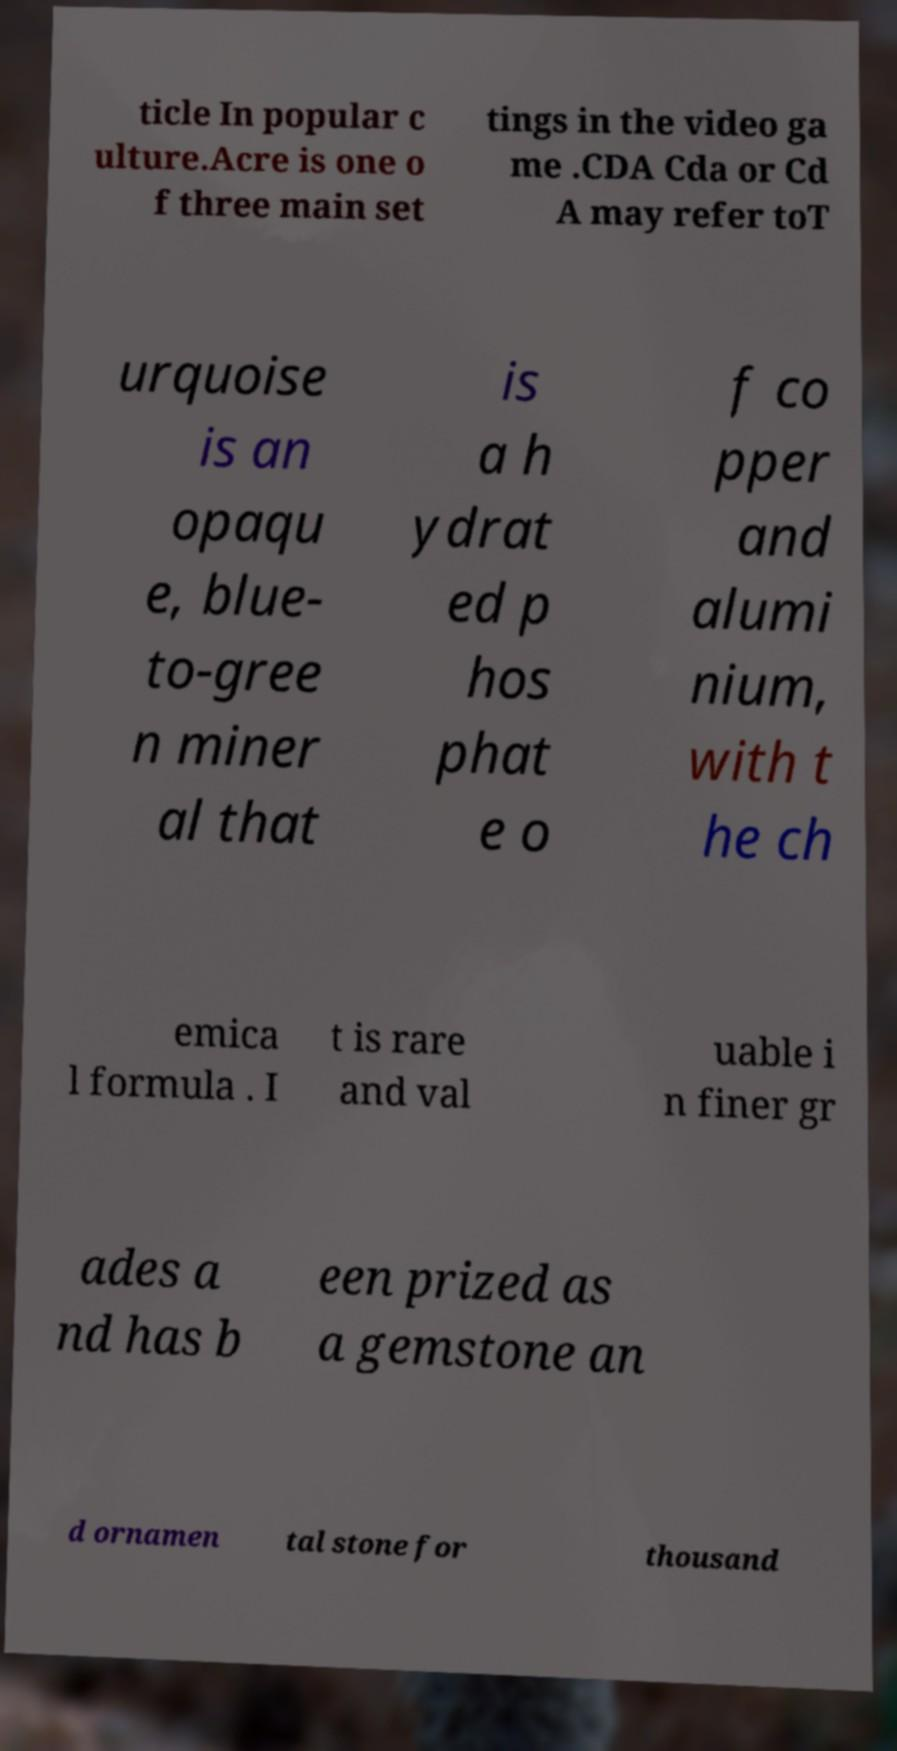Please read and relay the text visible in this image. What does it say? ticle In popular c ulture.Acre is one o f three main set tings in the video ga me .CDA Cda or Cd A may refer toT urquoise is an opaqu e, blue- to-gree n miner al that is a h ydrat ed p hos phat e o f co pper and alumi nium, with t he ch emica l formula . I t is rare and val uable i n finer gr ades a nd has b een prized as a gemstone an d ornamen tal stone for thousand 